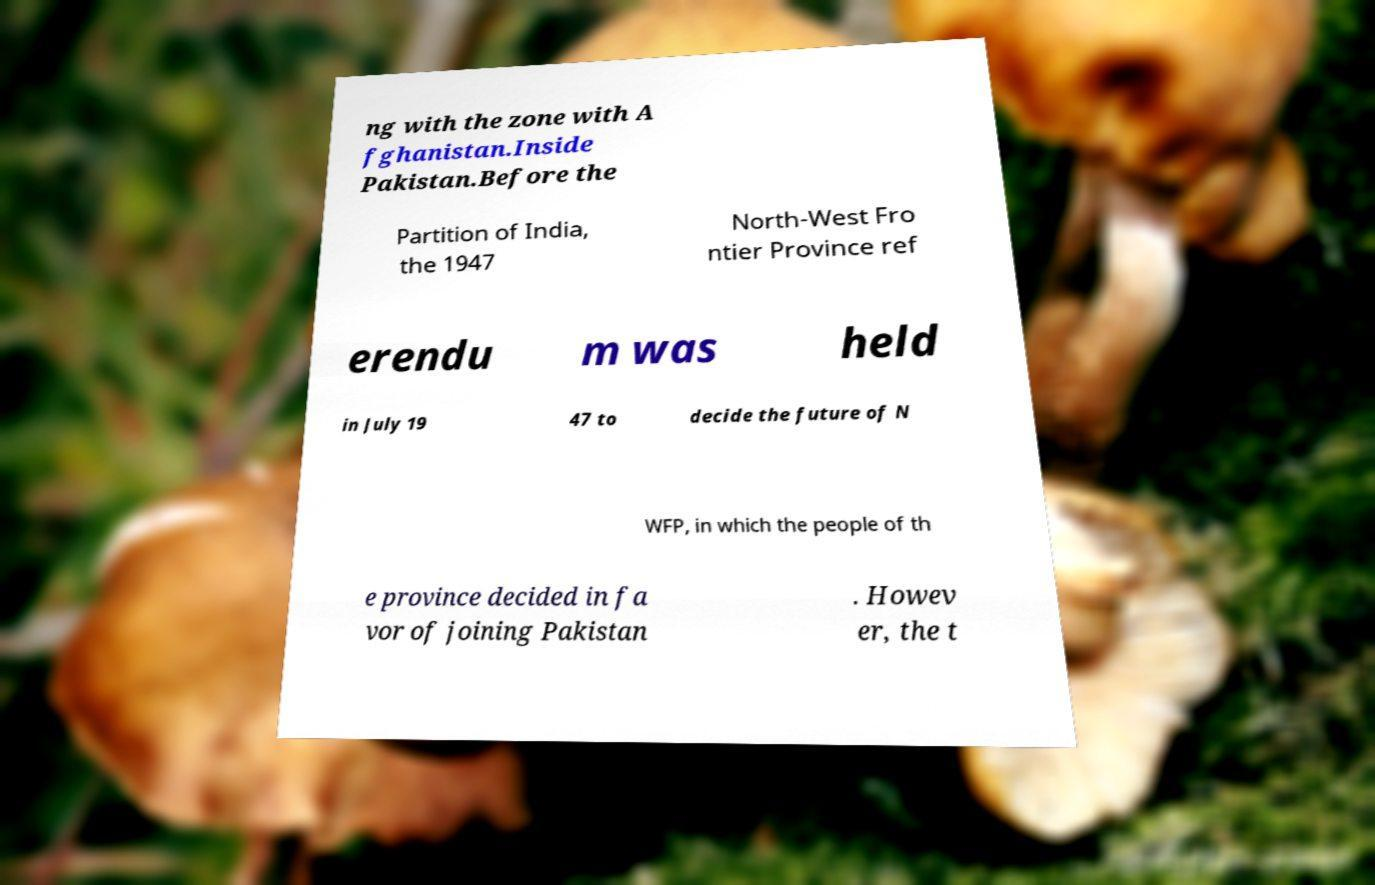Can you read and provide the text displayed in the image?This photo seems to have some interesting text. Can you extract and type it out for me? ng with the zone with A fghanistan.Inside Pakistan.Before the Partition of India, the 1947 North-West Fro ntier Province ref erendu m was held in July 19 47 to decide the future of N WFP, in which the people of th e province decided in fa vor of joining Pakistan . Howev er, the t 